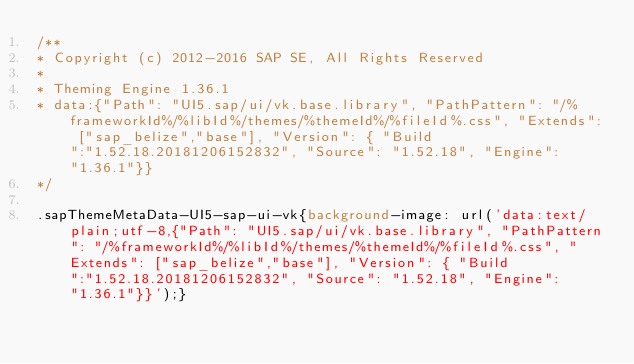<code> <loc_0><loc_0><loc_500><loc_500><_CSS_>/**
* Copyright (c) 2012-2016 SAP SE, All Rights Reserved
*
* Theming Engine 1.36.1
* data:{"Path": "UI5.sap/ui/vk.base.library", "PathPattern": "/%frameworkId%/%libId%/themes/%themeId%/%fileId%.css", "Extends": ["sap_belize","base"], "Version": { "Build":"1.52.18.20181206152832", "Source": "1.52.18", "Engine": "1.36.1"}}
*/

.sapThemeMetaData-UI5-sap-ui-vk{background-image: url('data:text/plain;utf-8,{"Path": "UI5.sap/ui/vk.base.library", "PathPattern": "/%frameworkId%/%libId%/themes/%themeId%/%fileId%.css", "Extends": ["sap_belize","base"], "Version": { "Build":"1.52.18.20181206152832", "Source": "1.52.18", "Engine": "1.36.1"}}');}</code> 